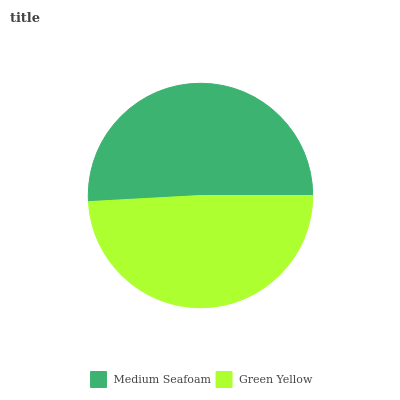Is Green Yellow the minimum?
Answer yes or no. Yes. Is Medium Seafoam the maximum?
Answer yes or no. Yes. Is Green Yellow the maximum?
Answer yes or no. No. Is Medium Seafoam greater than Green Yellow?
Answer yes or no. Yes. Is Green Yellow less than Medium Seafoam?
Answer yes or no. Yes. Is Green Yellow greater than Medium Seafoam?
Answer yes or no. No. Is Medium Seafoam less than Green Yellow?
Answer yes or no. No. Is Medium Seafoam the high median?
Answer yes or no. Yes. Is Green Yellow the low median?
Answer yes or no. Yes. Is Green Yellow the high median?
Answer yes or no. No. Is Medium Seafoam the low median?
Answer yes or no. No. 